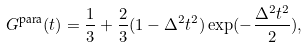<formula> <loc_0><loc_0><loc_500><loc_500>G ^ { \text {para} } ( t ) = \frac { 1 } { 3 } + \frac { 2 } { 3 } ( 1 - \Delta ^ { 2 } t ^ { 2 } ) \exp ( - \frac { \Delta ^ { 2 } t ^ { 2 } } { 2 } ) ,</formula> 